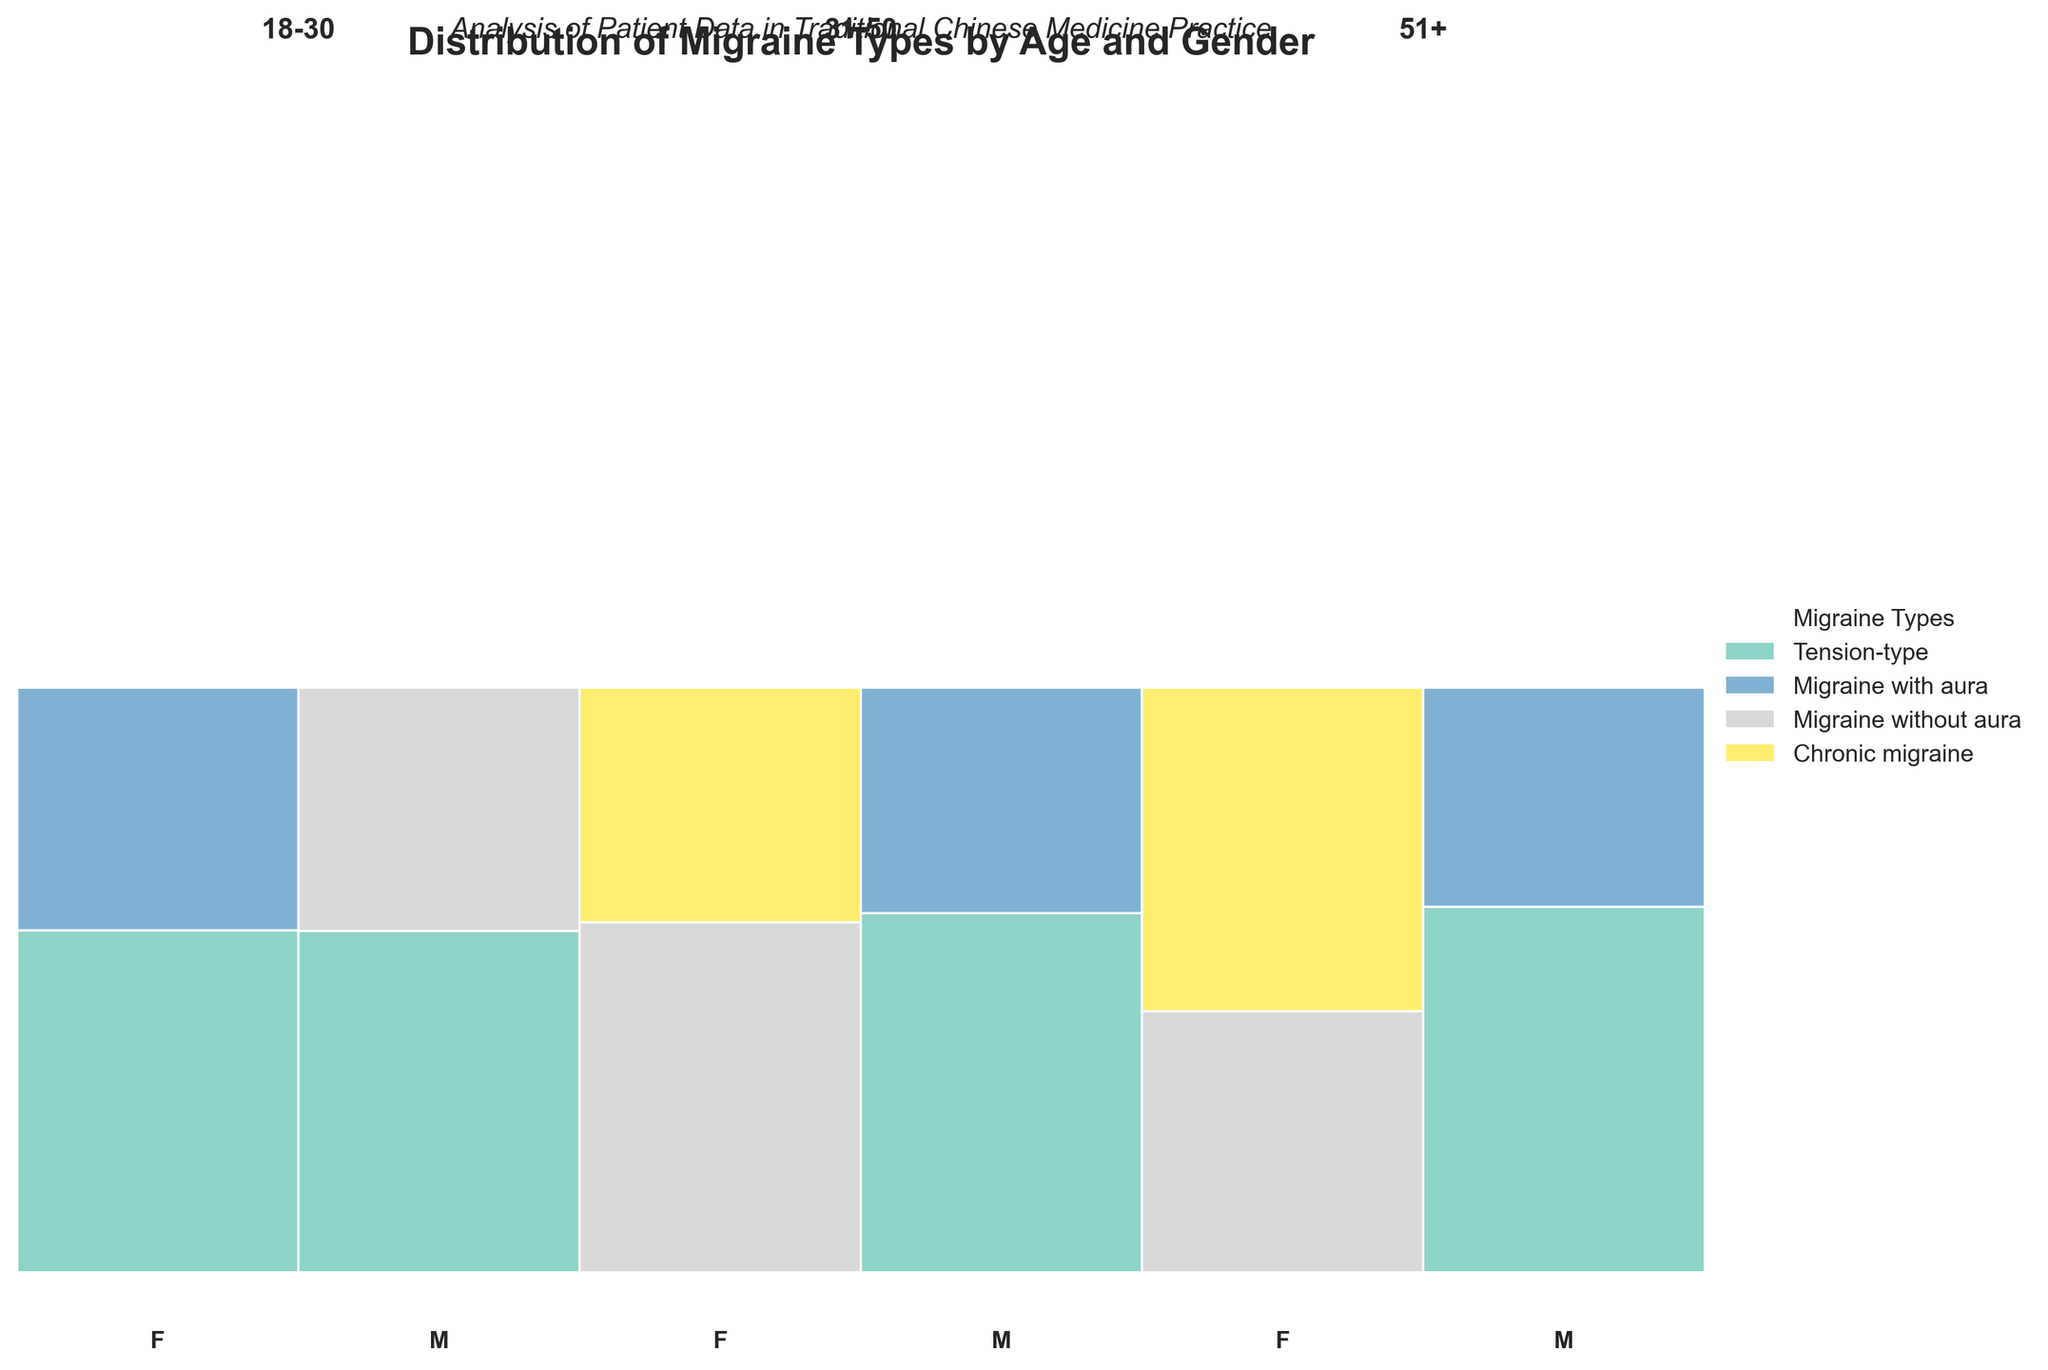What is the title of the figure? The title of the figure is displayed at the top and reads "Distribution of Migraine Types by Age and Gender".
Answer: Distribution of Migraine Types by Age and Gender Which age group has the highest proportion of tension-type migraines among males? In the male section of each age group, the proportion of the section colored for tension-type migraines appears largest in the 51+ age group.
Answer: 51+ For females aged 31-50, which migraine type is most common? In the female section of the 31-50 age group, the largest colored section corresponds to "Migraine without aura".
Answer: Migraine without aura What is the smallest segment in the entire mosaic plot? The smallest segment represents males aged 51+ with "Migraine with aura", as this segment is the smallest among all visible segments.
Answer: Males aged 51+ with Migraine with aura Comparing the age groups 18-30 and 51+, which gender has more chronic migraine cases? In the age group 51+, females have a segment representing chronic migraine, whereas in the age group 18-30, neither gender has a segment colored for chronic migraine, indicating that females aged 51+ have more chronic migraine cases than any other gender and age group combination within the 18-30 or 51+ groups.
Answer: Females in 51+ For the age group 18-30, how many migraine types are represented for males and females? For the age group 18-30, males have two segments representing "Tension-type" and "Migraine without aura". Females have two segments representing "Tension-type" and "Migraine with aura".
Answer: Two migraine types for both genders Which gender has a more diversified range of migraine types in the age group 31-50? Females aged 31-50 have segments for "Migraine without aura" and "Chronic migraine", while males aged 31-50 have segments for "Tension-type" and "Migraine with aura". Since the number of different migraine types is equal, neither gender has a more diversified range of migraine types within this age group.
Answer: Neither In terms of chronic migraine, which gender and age combination has the largest proportion within its group? By looking at the sections for chronic migraine in the mosaic plot, females aged 51+ have the largest proportion of chronic migraine within their age and gender group as indicated by the larger segment size compared to other groups.
Answer: Females aged 51+ How does the proportion of tension-type migraines compare between males aged 18-30 and 31-50? The proportion of tension-type migraines among males is larger in the 31-50 age group compared to the 18-30 age group, as indicated by a bigger segment size in the 31-50 age group.
Answer: Larger in 31-50 